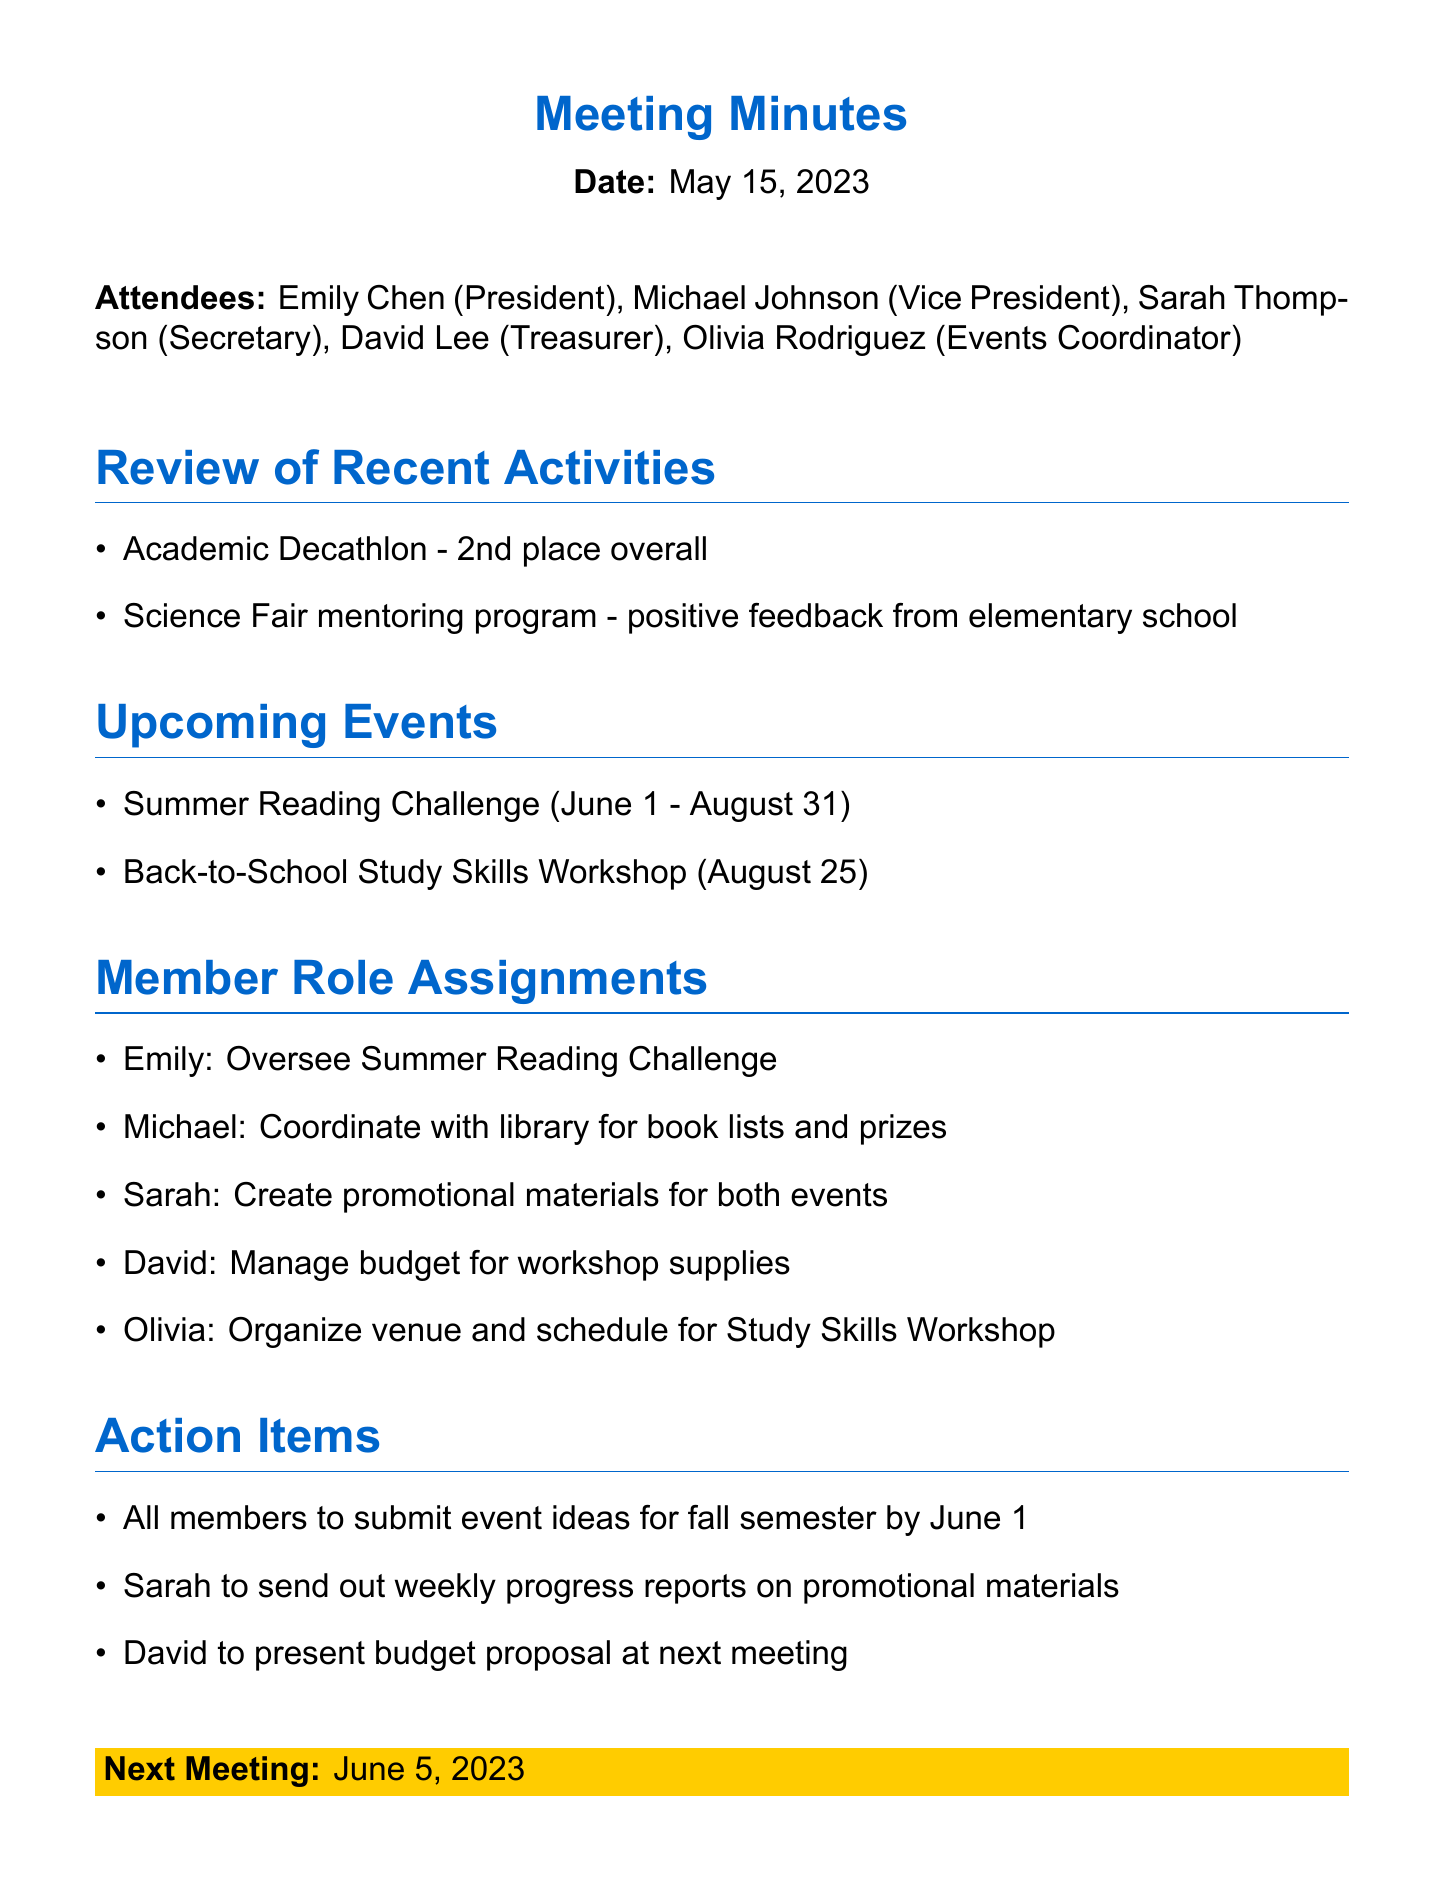What date was the meeting held? The meeting date is explicitly stated at the beginning of the document.
Answer: May 15, 2023 Who is the Events Coordinator? The document lists all attendees along with their roles, including the Events Coordinator's name.
Answer: Olivia Rodriguez What place did the Academic Decathlon achieve? The document states the outcome of the Academic Decathlon event in the review of recent activities section.
Answer: 2nd place When is the Summer Reading Challenge scheduled to occur? The schedule for the Summer Reading Challenge is provided in the upcoming events section.
Answer: June 1 - August 31 What is Michael's assigned role? Michael's specific task is outlined under member role assignments in the document.
Answer: Coordinate with library for book lists and prizes What action must all members take by June 1? The action items section indicates a specific requirement for all members related to the fall semester.
Answer: Submit event ideas What is Sarah responsible for in the upcoming events? Sarah's task is mentioned in the member role assignments section of the document.
Answer: Create promotional materials for both events When will the next meeting take place? The date of the next meeting is specified at the end of the document.
Answer: June 5, 2023 